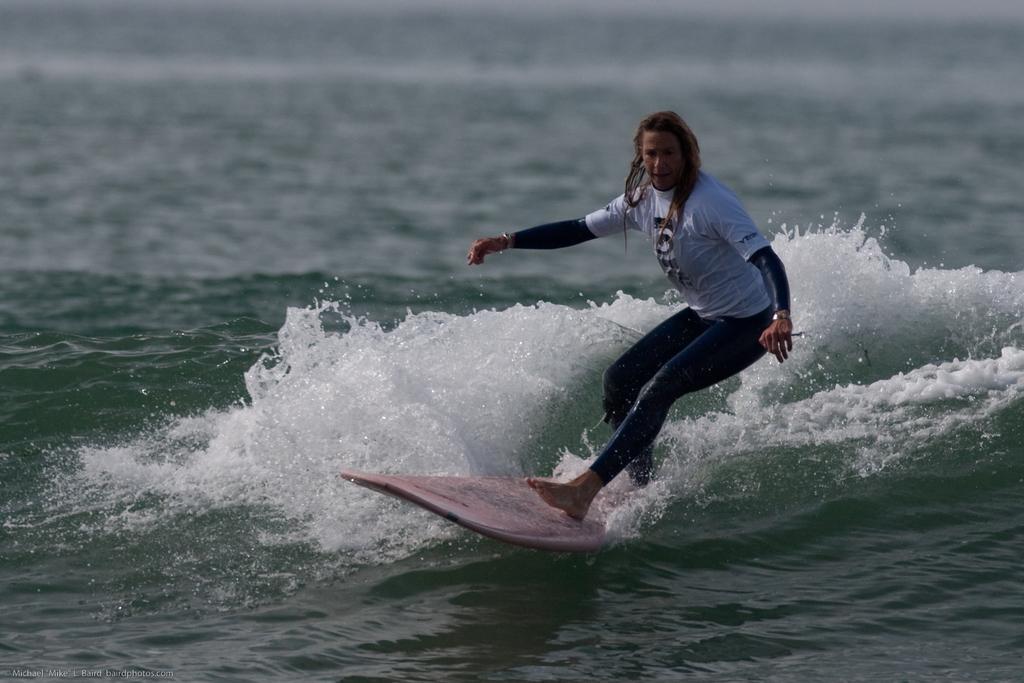Describe this image in one or two sentences. In this picture we can see a person standing on a surfboard and surfing on water. 